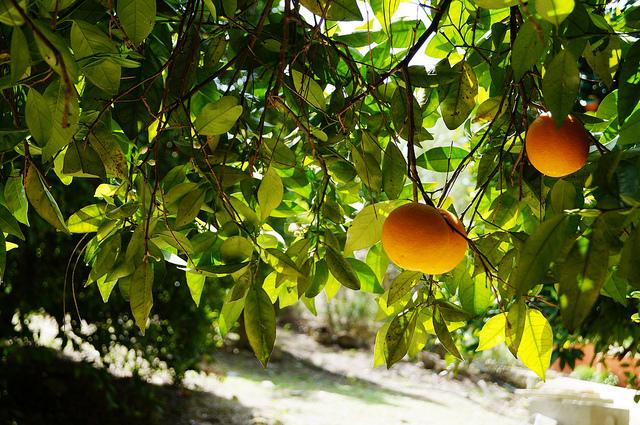How many oranges are there on the tree?
Write a very short answer. 2. Are these fruit ripe?
Answer briefly. Yes. What kind of fruit tree is this?
Write a very short answer. Orange. Is this an orange Grove?
Give a very brief answer. Yes. How many fruit is on the tree?
Write a very short answer. 2. 